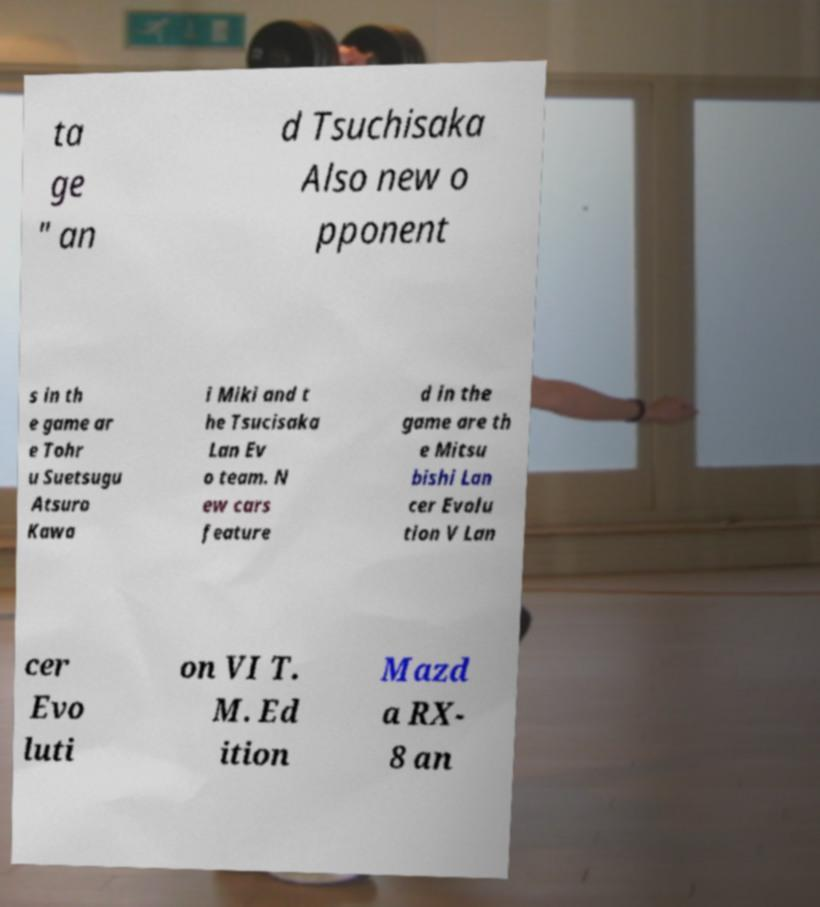What messages or text are displayed in this image? I need them in a readable, typed format. ta ge " an d Tsuchisaka Also new o pponent s in th e game ar e Tohr u Suetsugu Atsuro Kawa i Miki and t he Tsucisaka Lan Ev o team. N ew cars feature d in the game are th e Mitsu bishi Lan cer Evolu tion V Lan cer Evo luti on VI T. M. Ed ition Mazd a RX- 8 an 